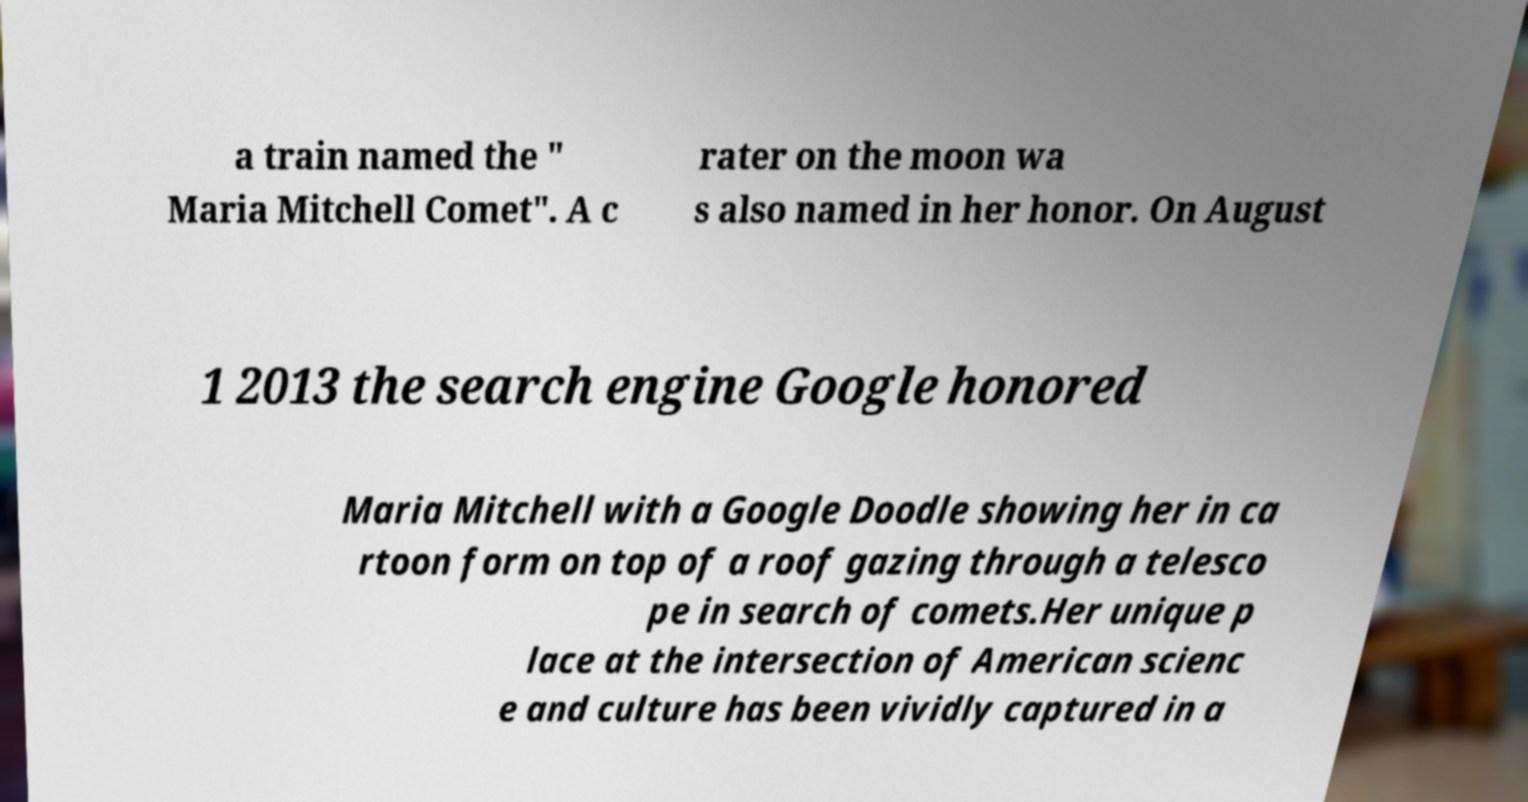I need the written content from this picture converted into text. Can you do that? a train named the " Maria Mitchell Comet". A c rater on the moon wa s also named in her honor. On August 1 2013 the search engine Google honored Maria Mitchell with a Google Doodle showing her in ca rtoon form on top of a roof gazing through a telesco pe in search of comets.Her unique p lace at the intersection of American scienc e and culture has been vividly captured in a 